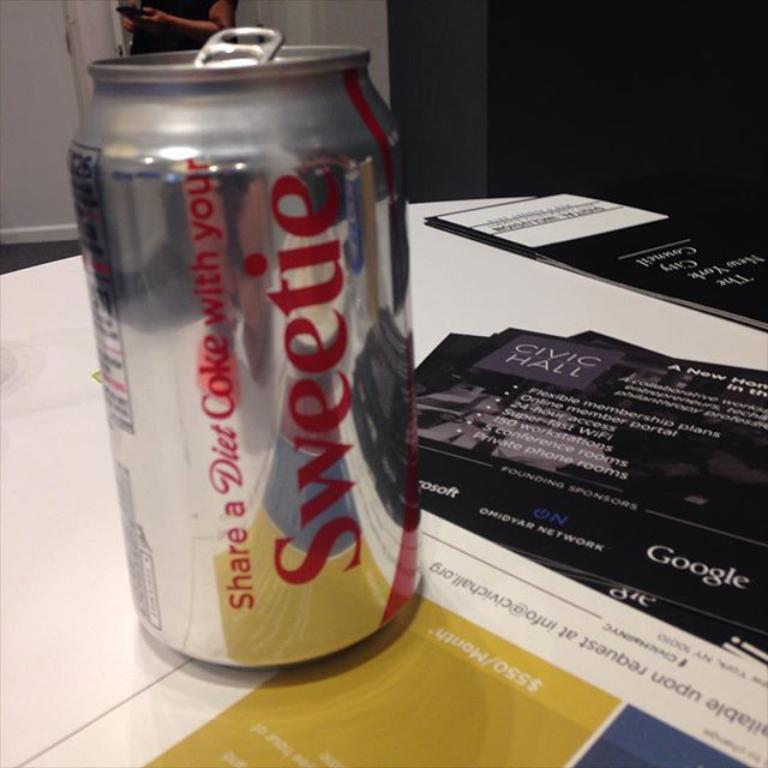<image>
Provide a brief description of the given image. A can of Diet Coke says "sweetie" on the side. 